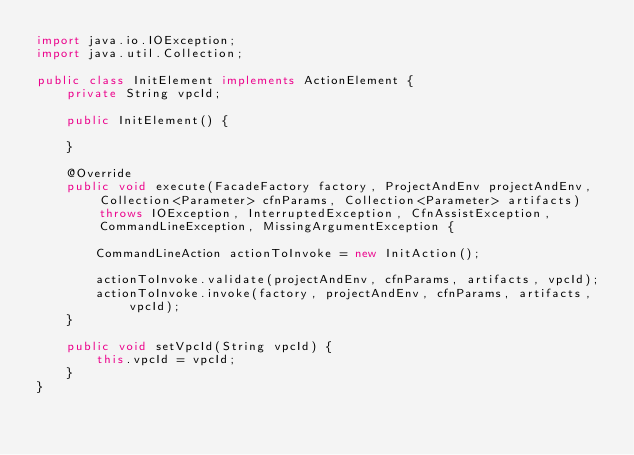Convert code to text. <code><loc_0><loc_0><loc_500><loc_500><_Java_>import java.io.IOException;
import java.util.Collection;

public class InitElement implements ActionElement {
    private String vpcId;

    public InitElement() {

    }

    @Override
    public void execute(FacadeFactory factory, ProjectAndEnv projectAndEnv, Collection<Parameter> cfnParams, Collection<Parameter> artifacts) throws IOException, InterruptedException, CfnAssistException, CommandLineException, MissingArgumentException {

        CommandLineAction actionToInvoke = new InitAction();

        actionToInvoke.validate(projectAndEnv, cfnParams, artifacts, vpcId);
        actionToInvoke.invoke(factory, projectAndEnv, cfnParams, artifacts, vpcId);
    }

    public void setVpcId(String vpcId) {
        this.vpcId = vpcId;
    }
}
</code> 